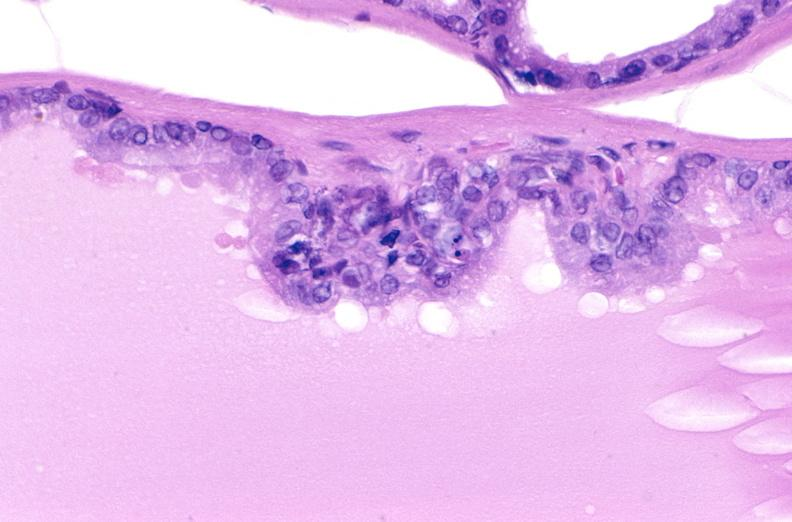when does this image show apoptosis in prostate?
Answer the question using a single word or phrase. After orchiectomy 